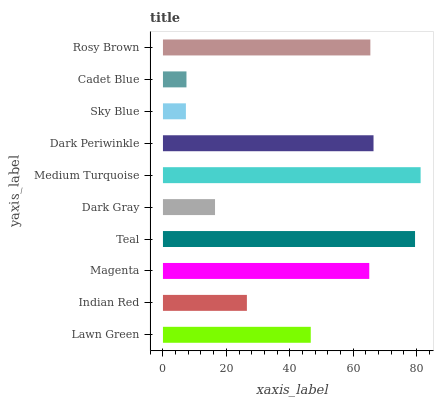Is Sky Blue the minimum?
Answer yes or no. Yes. Is Medium Turquoise the maximum?
Answer yes or no. Yes. Is Indian Red the minimum?
Answer yes or no. No. Is Indian Red the maximum?
Answer yes or no. No. Is Lawn Green greater than Indian Red?
Answer yes or no. Yes. Is Indian Red less than Lawn Green?
Answer yes or no. Yes. Is Indian Red greater than Lawn Green?
Answer yes or no. No. Is Lawn Green less than Indian Red?
Answer yes or no. No. Is Magenta the high median?
Answer yes or no. Yes. Is Lawn Green the low median?
Answer yes or no. Yes. Is Medium Turquoise the high median?
Answer yes or no. No. Is Medium Turquoise the low median?
Answer yes or no. No. 